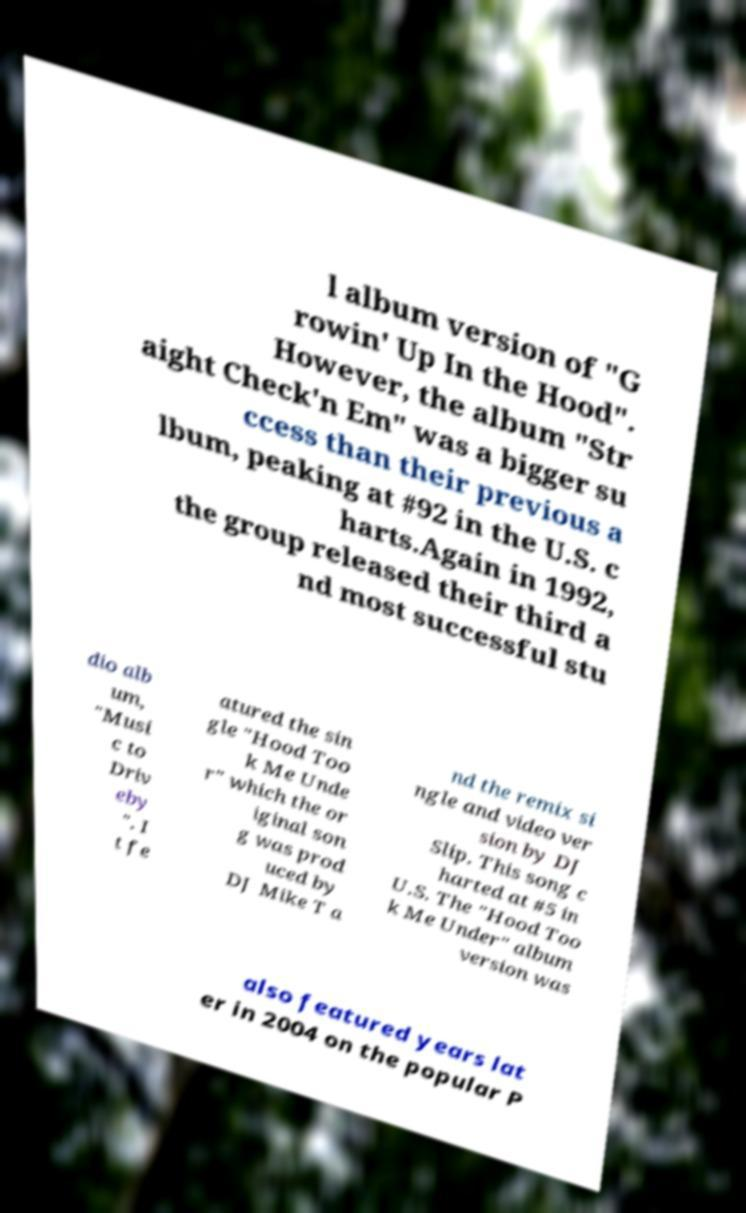I need the written content from this picture converted into text. Can you do that? l album version of "G rowin' Up In the Hood". However, the album "Str aight Check'n Em" was a bigger su ccess than their previous a lbum, peaking at #92 in the U.S. c harts.Again in 1992, the group released their third a nd most successful stu dio alb um, "Musi c to Driv eby ". I t fe atured the sin gle "Hood Too k Me Unde r" which the or iginal son g was prod uced by DJ Mike T a nd the remix si ngle and video ver sion by DJ Slip. This song c harted at #5 in U.S. The "Hood Too k Me Under" album version was also featured years lat er in 2004 on the popular P 